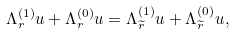Convert formula to latex. <formula><loc_0><loc_0><loc_500><loc_500>\Lambda _ { r } ^ { ( 1 ) } u + \Lambda _ { r } ^ { ( 0 ) } u = \Lambda _ { \widetilde { r } } ^ { ( 1 ) } u + \Lambda _ { \widetilde { r } } ^ { ( 0 ) } u ,</formula> 